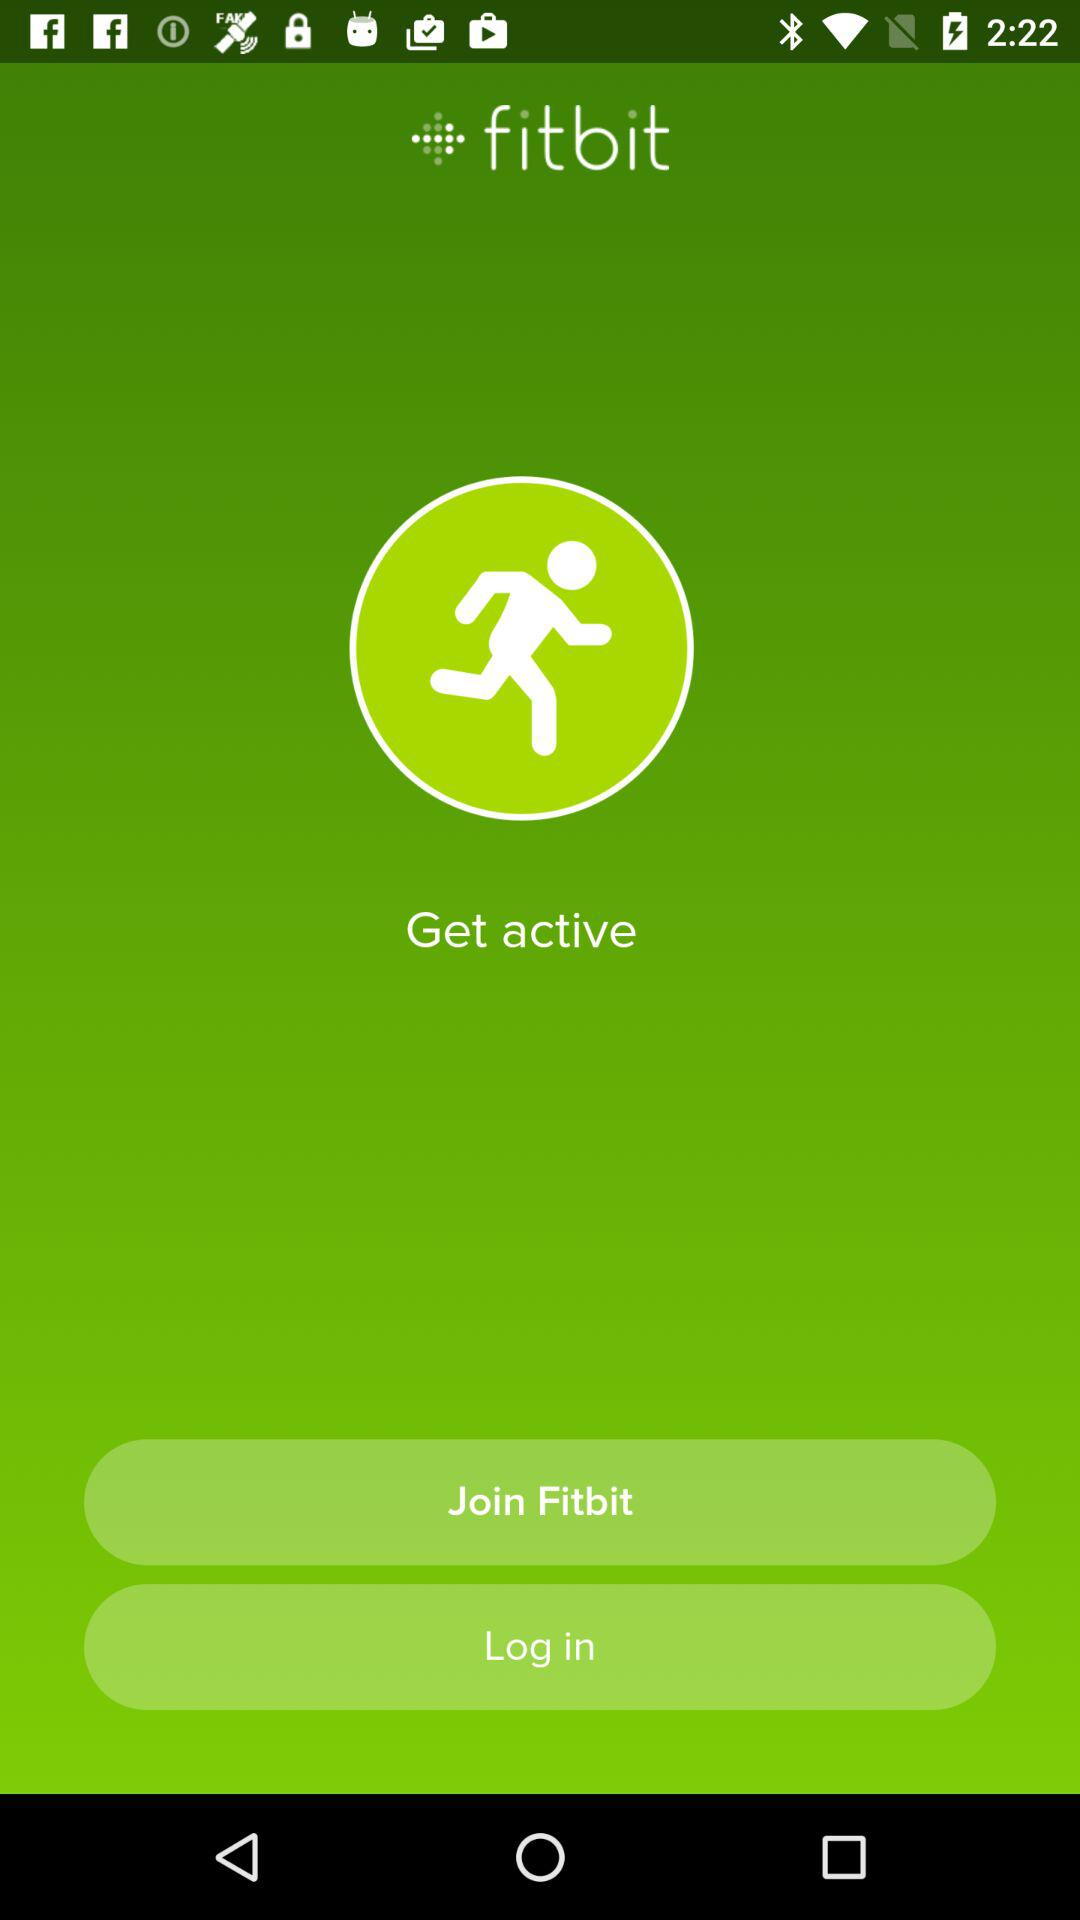What’s the app name? The app name is "fitbit". 